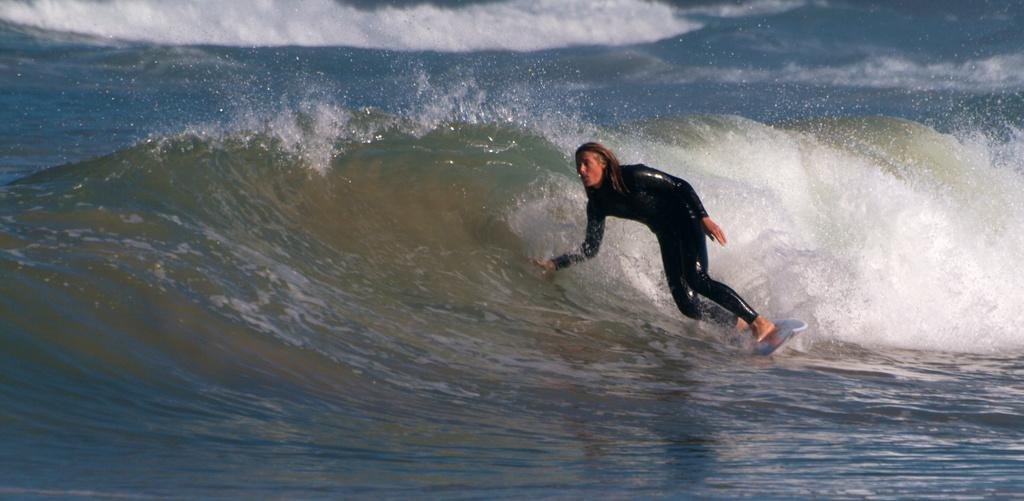Who is the main subject in the image? There is a lady in the image. Where is the lady located in the image? The lady is on the right side of the image. What is the lady doing in the image? The lady is surfing. What is the environment like in the image? There is water visible in the image. Does the lady use a toothbrush while surfing in the image? There is no toothbrush visible in the image, and it is not mentioned that the lady is using a toothbrush while surfing. 